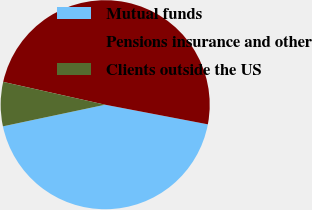Convert chart. <chart><loc_0><loc_0><loc_500><loc_500><pie_chart><fcel>Mutual funds<fcel>Pensions insurance and other<fcel>Clients outside the US<nl><fcel>43.68%<fcel>49.5%<fcel>6.82%<nl></chart> 